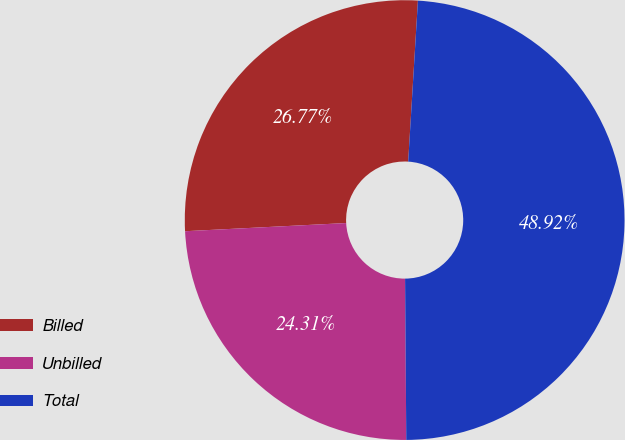Convert chart. <chart><loc_0><loc_0><loc_500><loc_500><pie_chart><fcel>Billed<fcel>Unbilled<fcel>Total<nl><fcel>26.77%<fcel>24.31%<fcel>48.92%<nl></chart> 